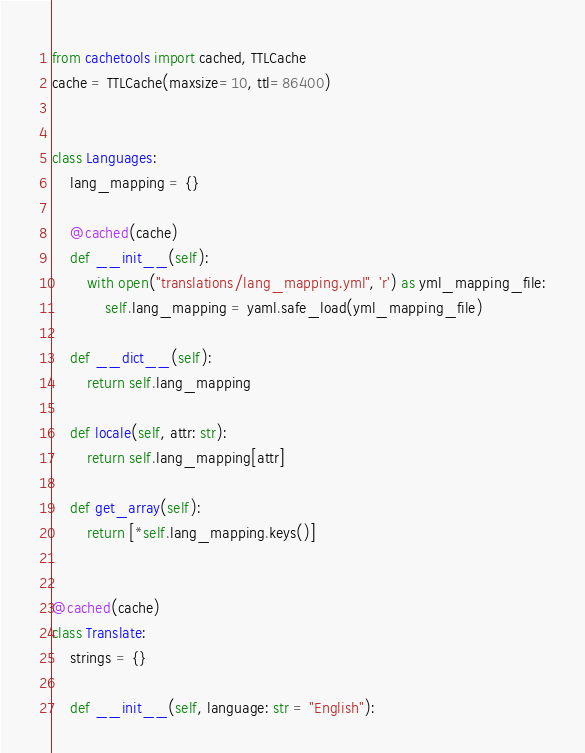Convert code to text. <code><loc_0><loc_0><loc_500><loc_500><_Python_>from cachetools import cached, TTLCache
cache = TTLCache(maxsize=10, ttl=86400)


class Languages:
    lang_mapping = {}

    @cached(cache)
    def __init__(self):
        with open("translations/lang_mapping.yml", 'r') as yml_mapping_file:
            self.lang_mapping = yaml.safe_load(yml_mapping_file)

    def __dict__(self):
        return self.lang_mapping

    def locale(self, attr: str):
        return self.lang_mapping[attr]

    def get_array(self):
        return [*self.lang_mapping.keys()]


@cached(cache)
class Translate:
    strings = {}

    def __init__(self, language: str = "English"):</code> 